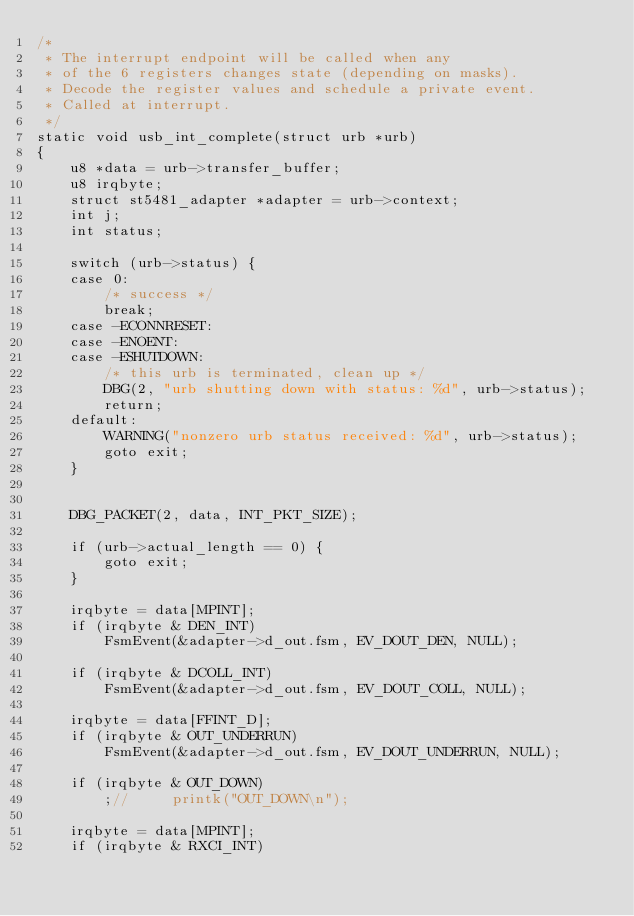Convert code to text. <code><loc_0><loc_0><loc_500><loc_500><_C_>/*
 * The interrupt endpoint will be called when any
 * of the 6 registers changes state (depending on masks).
 * Decode the register values and schedule a private event.
 * Called at interrupt.
 */
static void usb_int_complete(struct urb *urb)
{
	u8 *data = urb->transfer_buffer;
	u8 irqbyte;
	struct st5481_adapter *adapter = urb->context;
	int j;
	int status;

	switch (urb->status) {
	case 0:
		/* success */
		break;
	case -ECONNRESET:
	case -ENOENT:
	case -ESHUTDOWN:
		/* this urb is terminated, clean up */
		DBG(2, "urb shutting down with status: %d", urb->status);
		return;
	default:
		WARNING("nonzero urb status received: %d", urb->status);
		goto exit;
	}


	DBG_PACKET(2, data, INT_PKT_SIZE);

	if (urb->actual_length == 0) {
		goto exit;
	}

	irqbyte = data[MPINT];
	if (irqbyte & DEN_INT)
		FsmEvent(&adapter->d_out.fsm, EV_DOUT_DEN, NULL);

	if (irqbyte & DCOLL_INT)
		FsmEvent(&adapter->d_out.fsm, EV_DOUT_COLL, NULL);

	irqbyte = data[FFINT_D];
	if (irqbyte & OUT_UNDERRUN)
		FsmEvent(&adapter->d_out.fsm, EV_DOUT_UNDERRUN, NULL);

	if (irqbyte & OUT_DOWN)
		;//		printk("OUT_DOWN\n");

	irqbyte = data[MPINT];
	if (irqbyte & RXCI_INT)</code> 